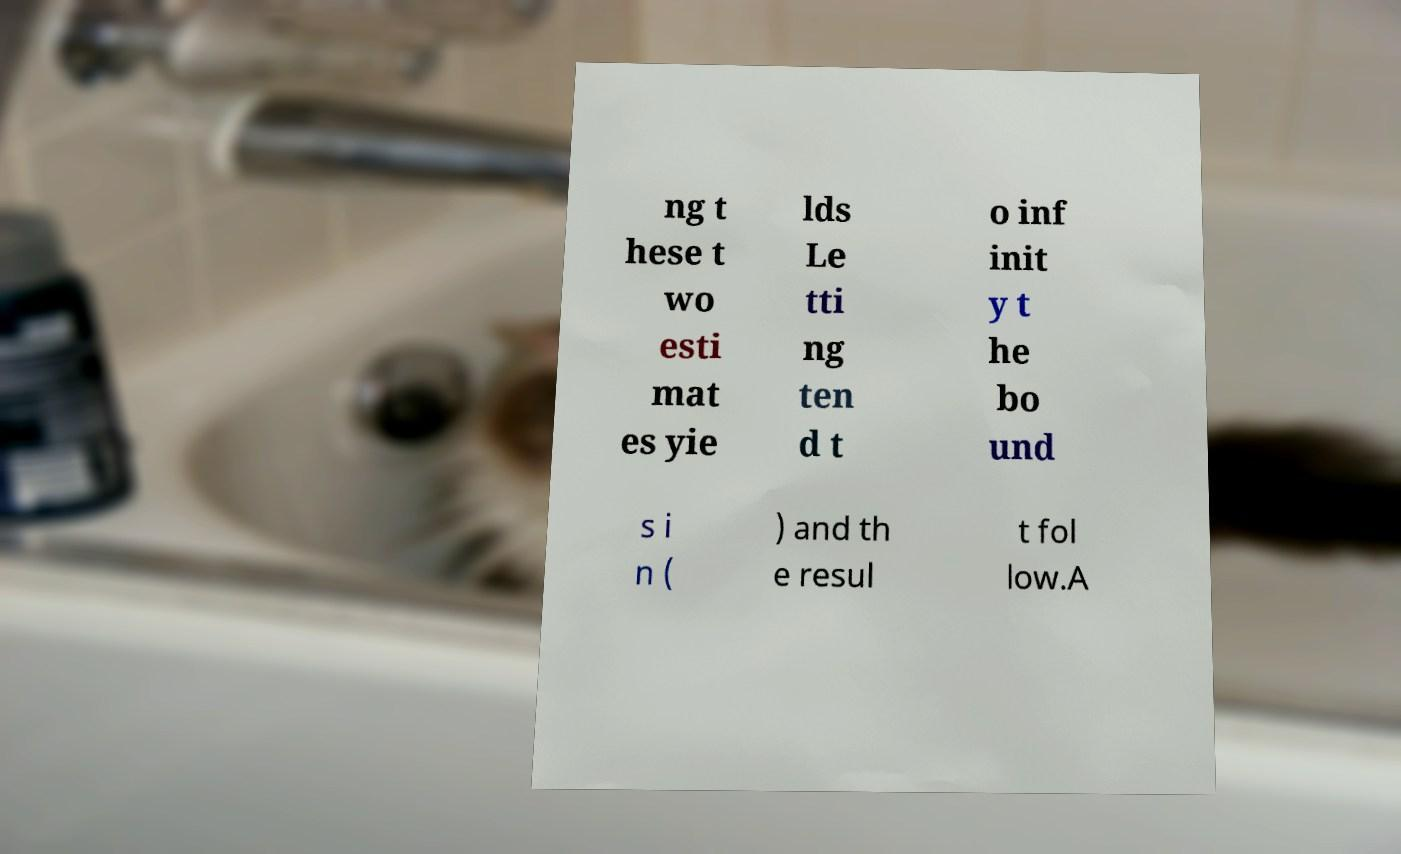Can you accurately transcribe the text from the provided image for me? ng t hese t wo esti mat es yie lds Le tti ng ten d t o inf init y t he bo und s i n ( ) and th e resul t fol low.A 